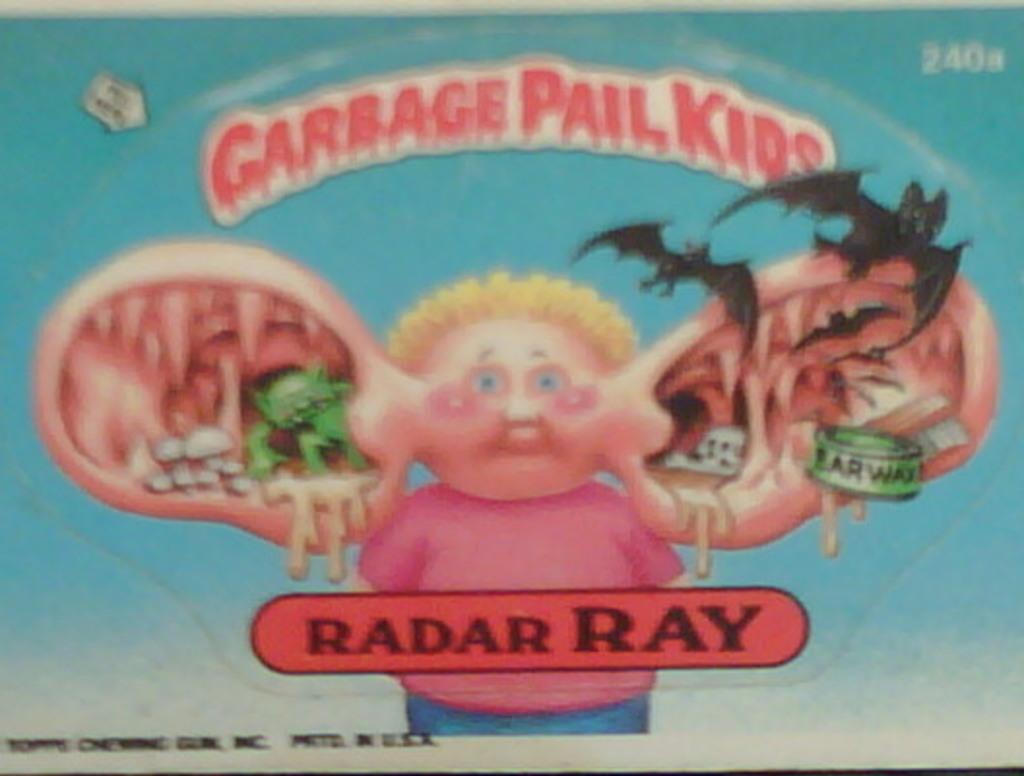What kind of pail kids?
Offer a very short reply. Garbage. What does the can in the ear say?
Make the answer very short. Ear wax. 